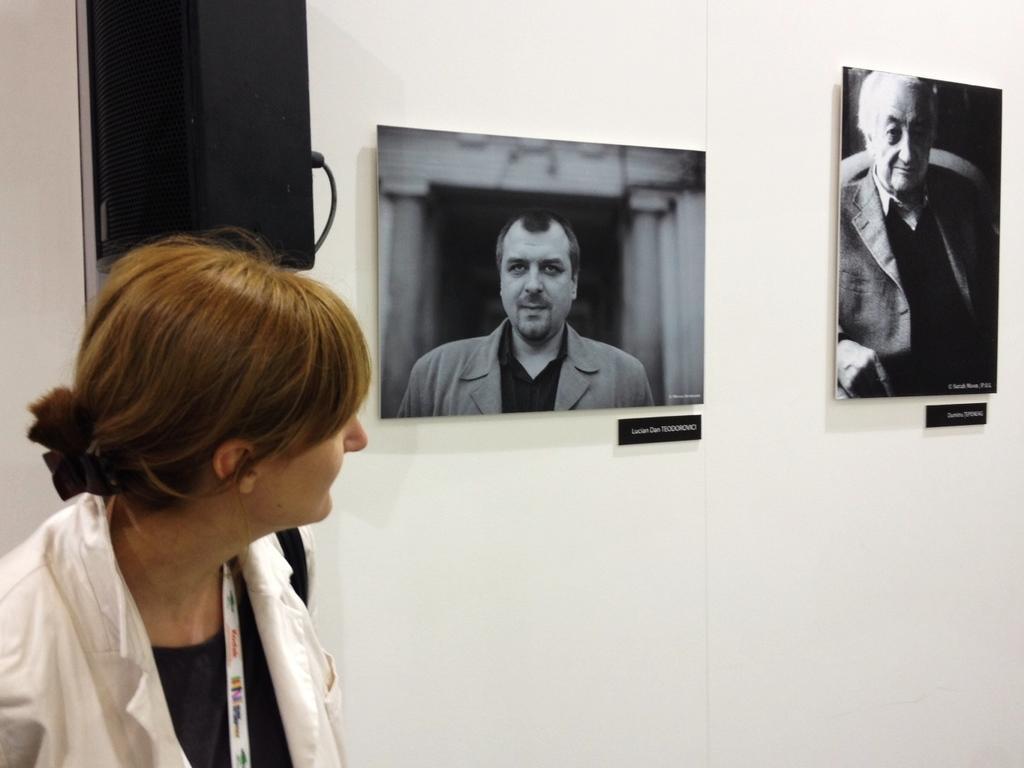Describe this image in one or two sentences. In this image, we can see a person in front of the wall. There is a speaker in the top left of the image. There are photos on the wall. 